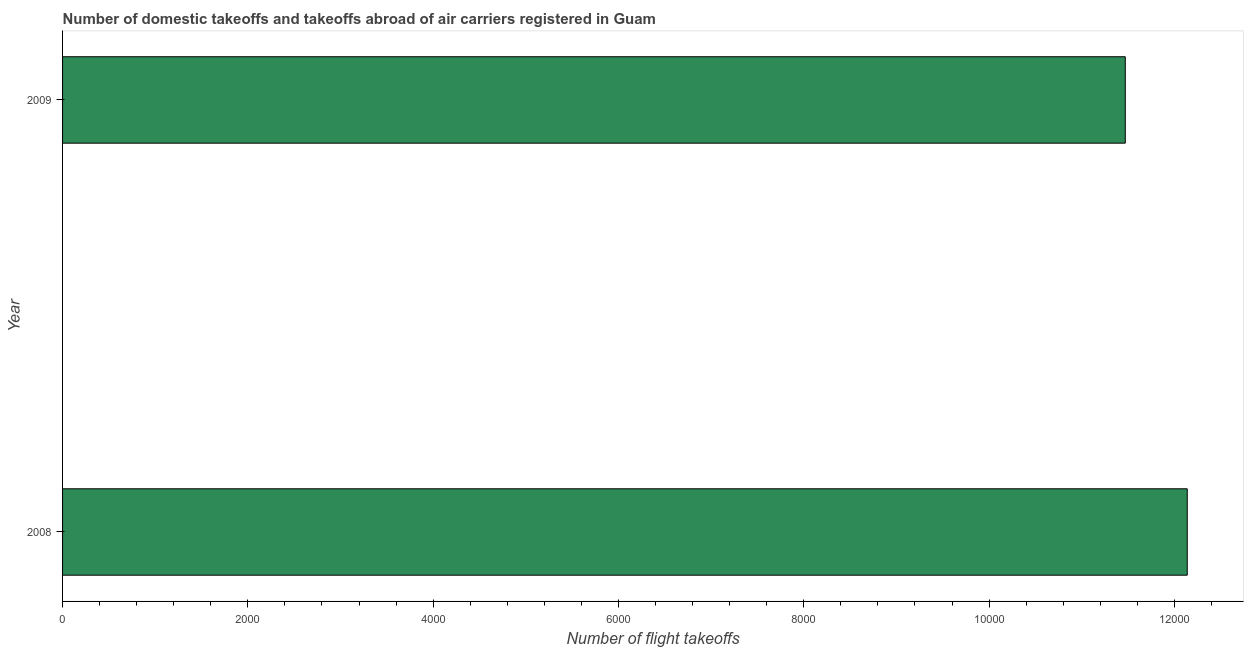What is the title of the graph?
Your response must be concise. Number of domestic takeoffs and takeoffs abroad of air carriers registered in Guam. What is the label or title of the X-axis?
Offer a terse response. Number of flight takeoffs. What is the number of flight takeoffs in 2008?
Offer a terse response. 1.21e+04. Across all years, what is the maximum number of flight takeoffs?
Offer a terse response. 1.21e+04. Across all years, what is the minimum number of flight takeoffs?
Ensure brevity in your answer.  1.15e+04. In which year was the number of flight takeoffs maximum?
Offer a very short reply. 2008. What is the sum of the number of flight takeoffs?
Provide a short and direct response. 2.36e+04. What is the difference between the number of flight takeoffs in 2008 and 2009?
Give a very brief answer. 669. What is the average number of flight takeoffs per year?
Ensure brevity in your answer.  1.18e+04. What is the median number of flight takeoffs?
Offer a terse response. 1.18e+04. In how many years, is the number of flight takeoffs greater than 6400 ?
Offer a terse response. 2. Do a majority of the years between 2008 and 2009 (inclusive) have number of flight takeoffs greater than 5200 ?
Provide a succinct answer. Yes. What is the ratio of the number of flight takeoffs in 2008 to that in 2009?
Make the answer very short. 1.06. How many bars are there?
Make the answer very short. 2. Are all the bars in the graph horizontal?
Ensure brevity in your answer.  Yes. Are the values on the major ticks of X-axis written in scientific E-notation?
Offer a terse response. No. What is the Number of flight takeoffs in 2008?
Your answer should be very brief. 1.21e+04. What is the Number of flight takeoffs of 2009?
Give a very brief answer. 1.15e+04. What is the difference between the Number of flight takeoffs in 2008 and 2009?
Keep it short and to the point. 669. What is the ratio of the Number of flight takeoffs in 2008 to that in 2009?
Make the answer very short. 1.06. 